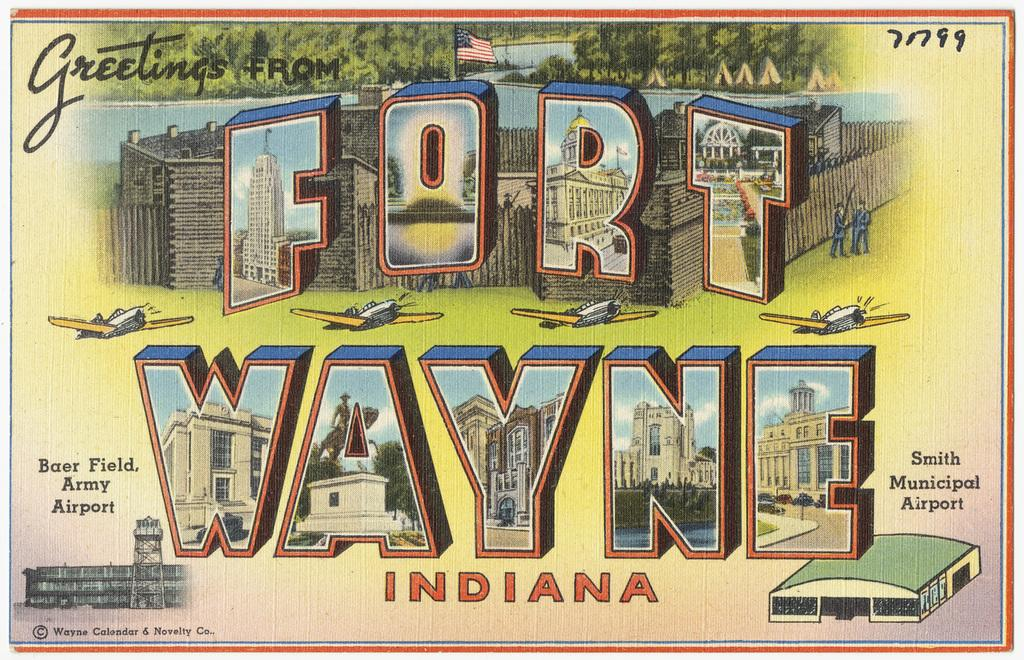Provide a one-sentence caption for the provided image. A post card from Fort Wayne Indiana from Baer Field Army airport. 